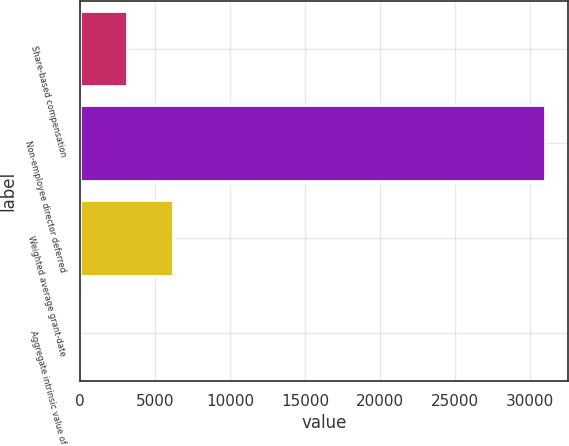Convert chart. <chart><loc_0><loc_0><loc_500><loc_500><bar_chart><fcel>Share-based compensation<fcel>Non-employee director deferred<fcel>Weighted average grant-date<fcel>Aggregate intrinsic value of<nl><fcel>3100.63<fcel>31000<fcel>6200.56<fcel>0.7<nl></chart> 